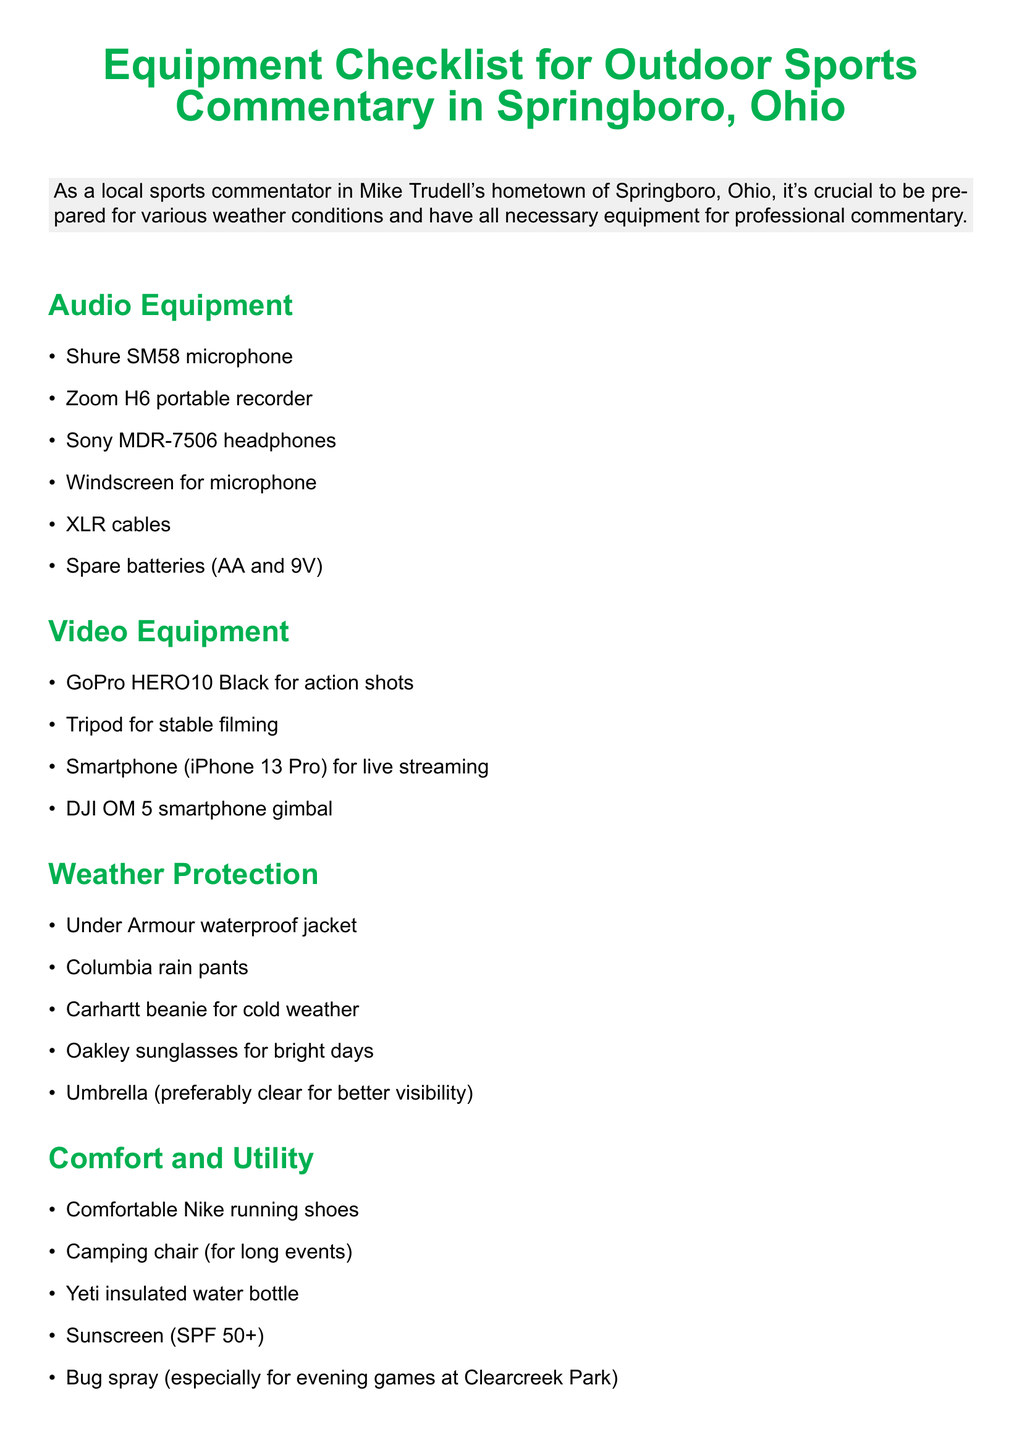What is the title of the memo? The title of the memo is presented at the top, summarizing the subject of the document.
Answer: Equipment Checklist for Outdoor Sports Commentary in Springboro, Ohio How many types of equipment categories are listed? The memo includes five distinct categories of equipment essential for commentary.
Answer: 5 What is one item listed under Audio Equipment? The memo specifies various items under each category, including those for audio purposes.
Answer: Shure SM58 microphone Which brand of mobile device is mentioned for live streaming? One type of video equipment mentioned pertains to live streaming capabilities.
Answer: iPhone 13 Pro What kind of weather protection gear is mentioned for cold weather? The memo details specific items to protect against various weather conditions, including cold.
Answer: Carhartt beanie What is one suggested item for comfort during long events? Comfort items listed are aimed to enhance the experience during extended commentary events.
Answer: Camping chair What is recommended besides the weather protection gear on clear days? The document advises on protection against bright weather conditions as part of its guidelines.
Answer: Oakley sunglasses What should you do before each event according to the additional notes? The additional notes section provides practical advice related to preparation for events.
Answer: Check Springboro weather forecast Name one type of tool listed for information resources. The information resources section includes various tools for assisting commentary.
Answer: iPad with cellular data 